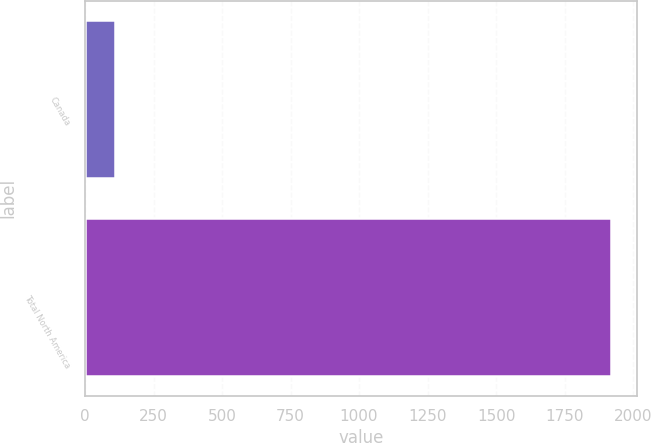Convert chart. <chart><loc_0><loc_0><loc_500><loc_500><bar_chart><fcel>Canada<fcel>Total North America<nl><fcel>111<fcel>1920<nl></chart> 